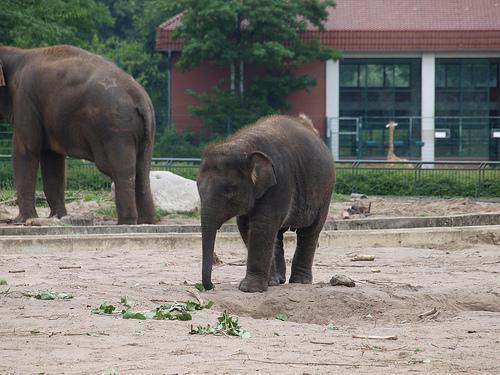How many elephants are there?
Give a very brief answer. 2. 